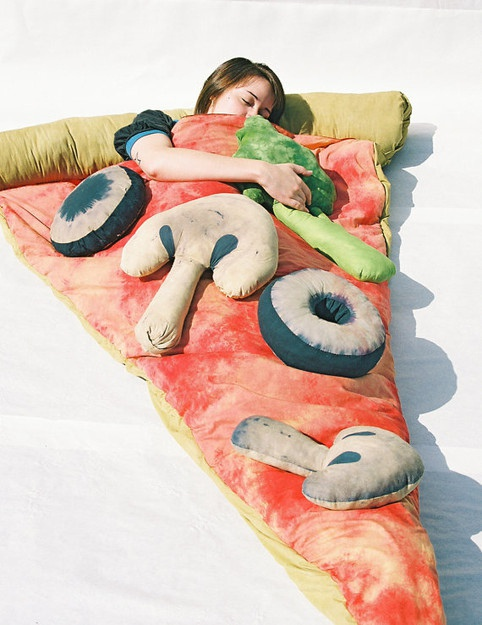Describe the objects in this image and their specific colors. I can see bed in white, tan, and salmon tones and people in white, lightgray, tan, and black tones in this image. 